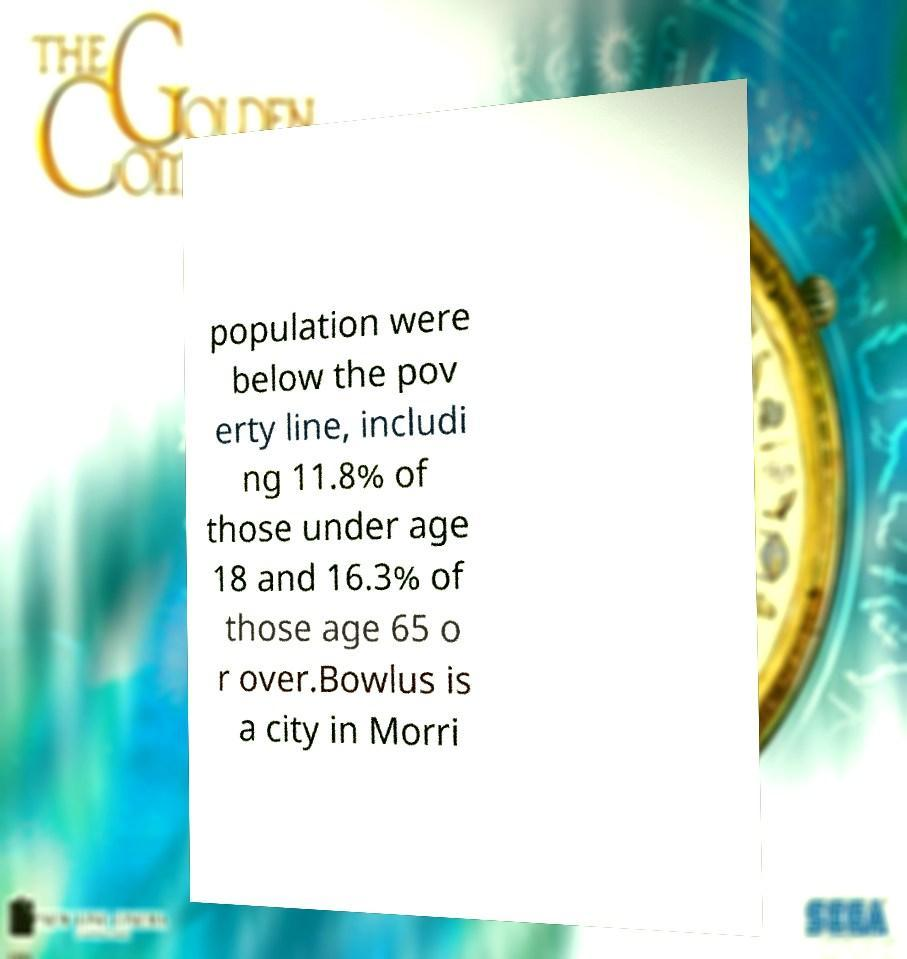Can you read and provide the text displayed in the image?This photo seems to have some interesting text. Can you extract and type it out for me? population were below the pov erty line, includi ng 11.8% of those under age 18 and 16.3% of those age 65 o r over.Bowlus is a city in Morri 